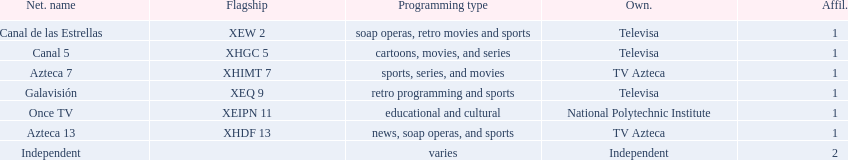Who are the owners of the stations listed here? Televisa, Televisa, TV Azteca, Televisa, National Polytechnic Institute, TV Azteca, Independent. What is the one station owned by national polytechnic institute? Once TV. 